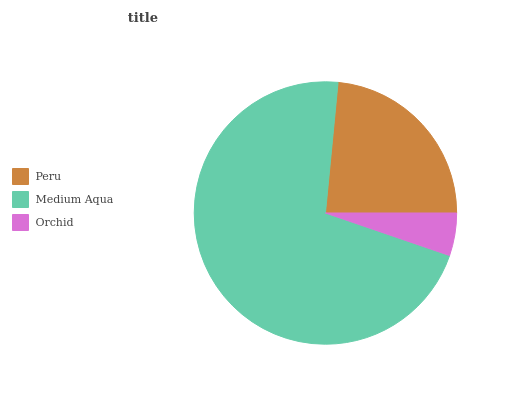Is Orchid the minimum?
Answer yes or no. Yes. Is Medium Aqua the maximum?
Answer yes or no. Yes. Is Medium Aqua the minimum?
Answer yes or no. No. Is Orchid the maximum?
Answer yes or no. No. Is Medium Aqua greater than Orchid?
Answer yes or no. Yes. Is Orchid less than Medium Aqua?
Answer yes or no. Yes. Is Orchid greater than Medium Aqua?
Answer yes or no. No. Is Medium Aqua less than Orchid?
Answer yes or no. No. Is Peru the high median?
Answer yes or no. Yes. Is Peru the low median?
Answer yes or no. Yes. Is Orchid the high median?
Answer yes or no. No. Is Medium Aqua the low median?
Answer yes or no. No. 